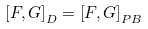Convert formula to latex. <formula><loc_0><loc_0><loc_500><loc_500>\left [ F , G \right ] _ { D } = \left [ F , G \right ] _ { P B }</formula> 